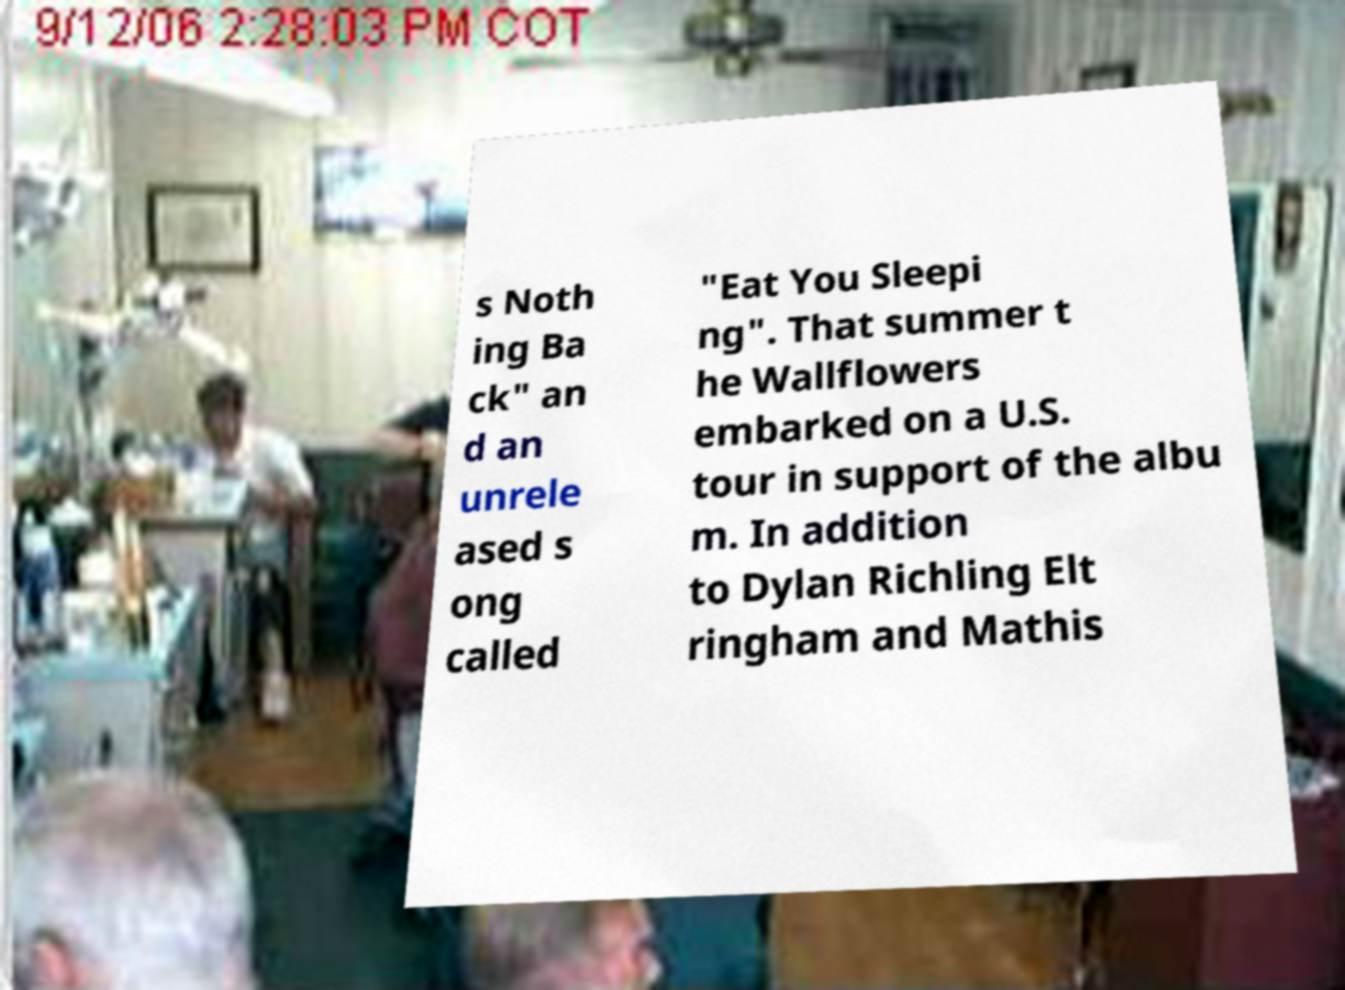Could you assist in decoding the text presented in this image and type it out clearly? s Noth ing Ba ck" an d an unrele ased s ong called "Eat You Sleepi ng". That summer t he Wallflowers embarked on a U.S. tour in support of the albu m. In addition to Dylan Richling Elt ringham and Mathis 